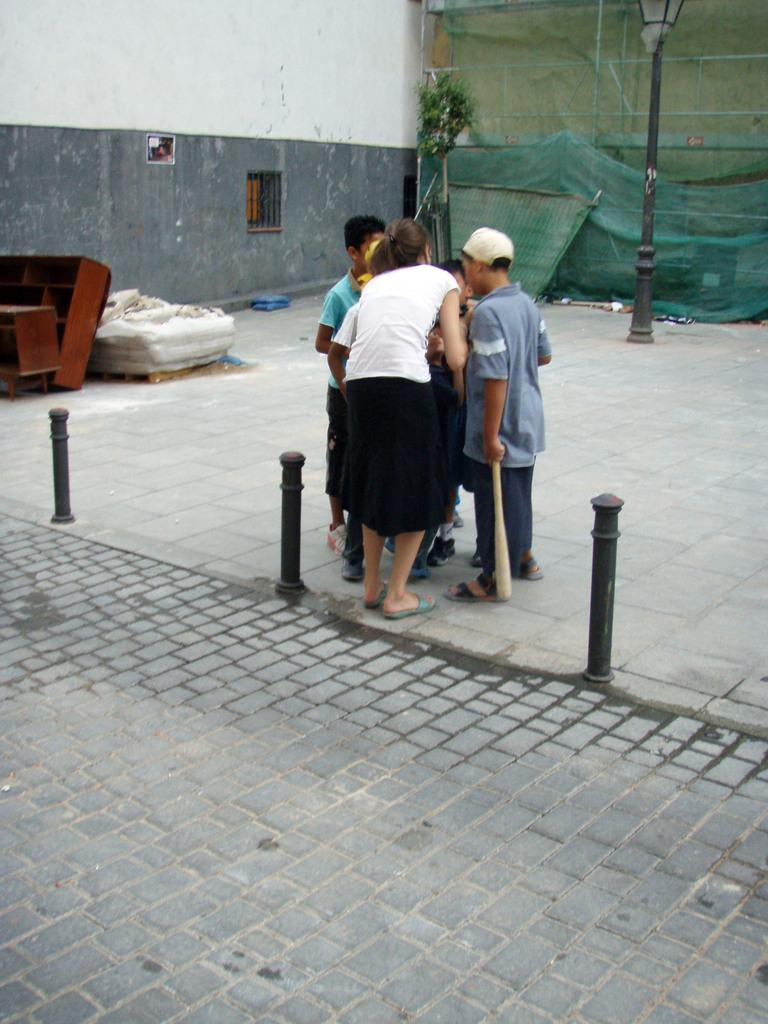What are the persons in the center of the image doing? The persons in the center of the image are holding bats. What can be seen in the background of the image? There is a wall, plants, a sheet, a net, and a streetlight visible in the background. Can you describe the additional objects around the persons and the background? There are additional objects around the persons and the background, but their specific details are not mentioned in the provided facts. What type of form is the crate used for in the image? There is no crate present in the image. What kind of trouble are the persons facing in the image? There is no indication of trouble or any negative situation in the image. 